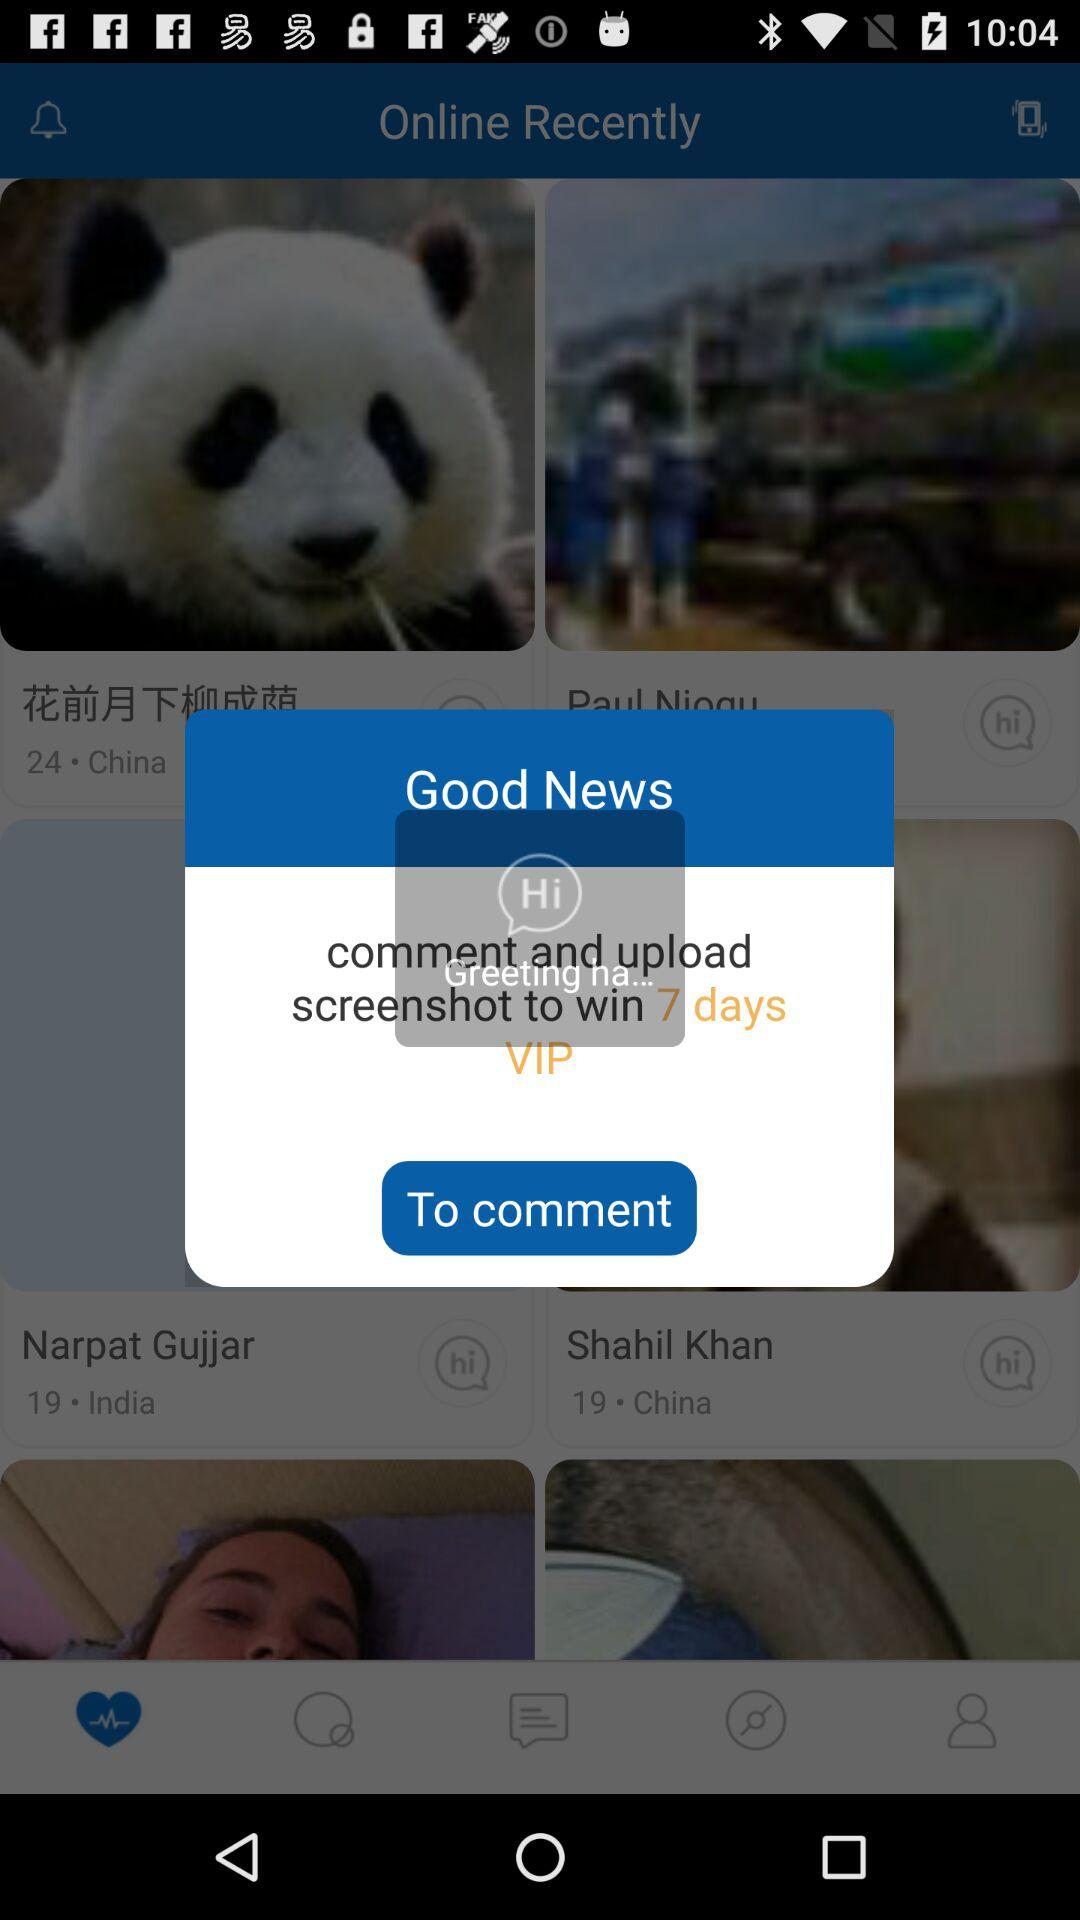What should you do to win a 7-day VIP pass? You should comment and upload the screenshot. 